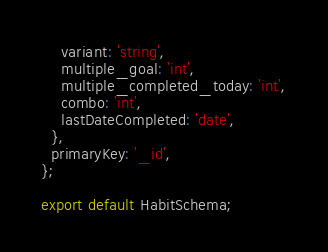<code> <loc_0><loc_0><loc_500><loc_500><_TypeScript_>    variant: 'string',
    multiple_goal: 'int',
    multiple_completed_today: 'int',
    combo: 'int',
    lastDateCompleted: 'date',
  },
  primaryKey: '_id',
};

export default HabitSchema;
</code> 